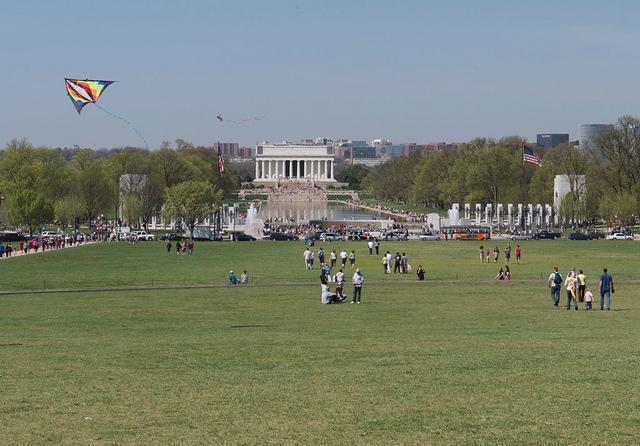In which country is this park located?
From the following set of four choices, select the accurate answer to respond to the question.
Options: United states, venezuela, mexico, canada. United states. 